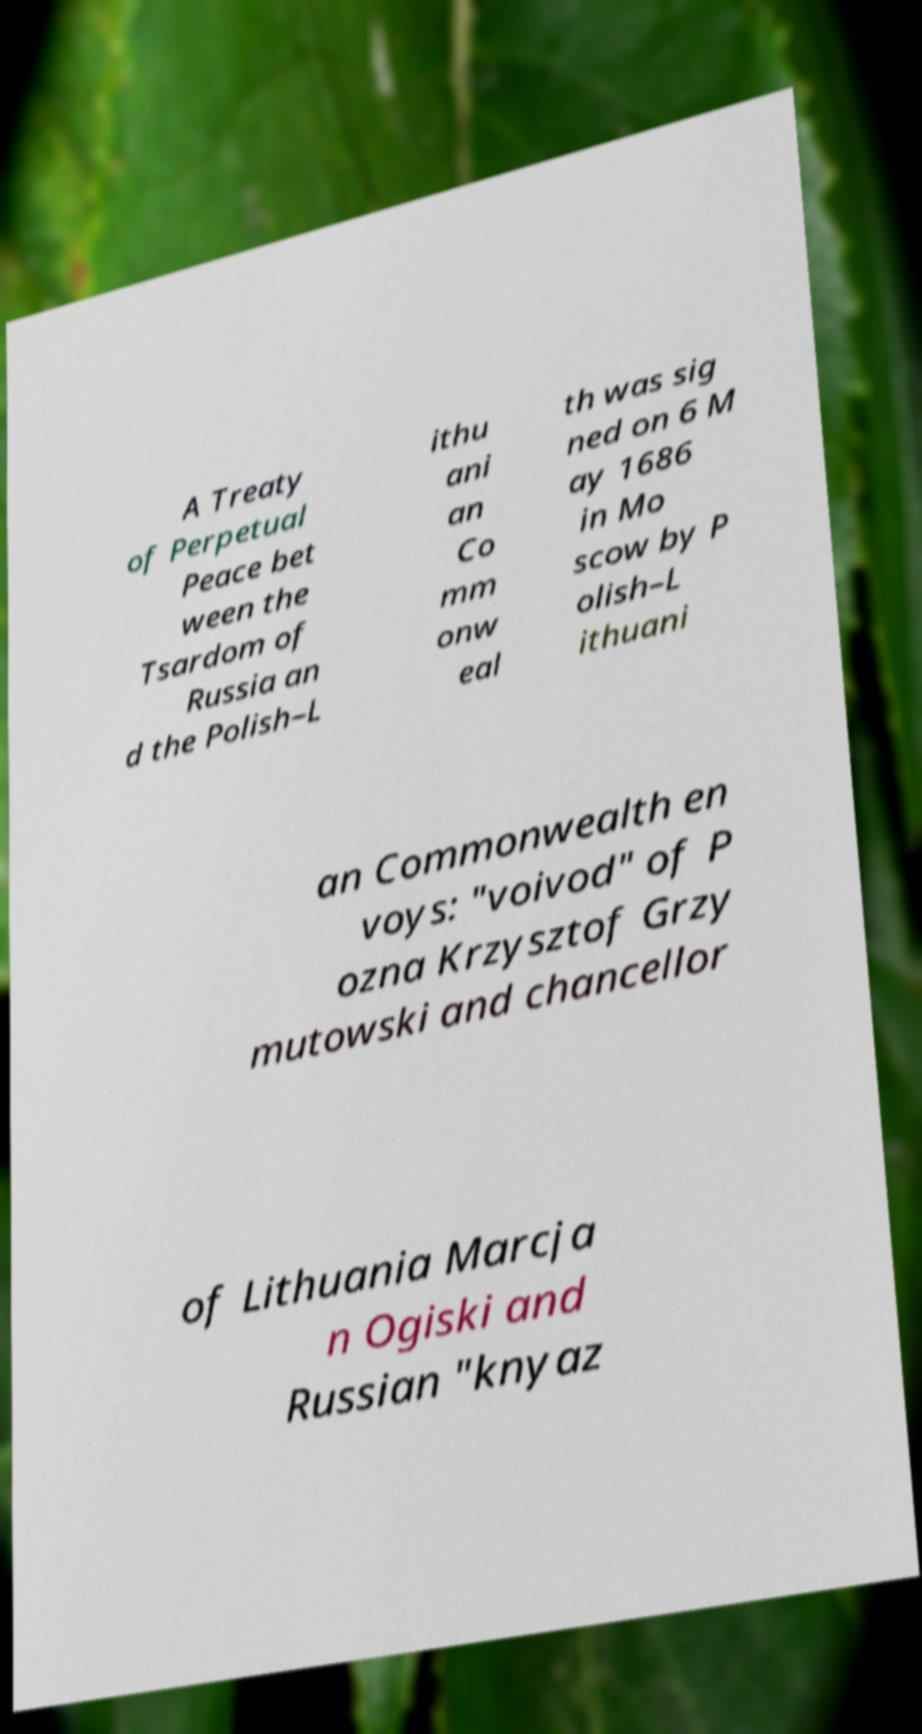Could you extract and type out the text from this image? A Treaty of Perpetual Peace bet ween the Tsardom of Russia an d the Polish–L ithu ani an Co mm onw eal th was sig ned on 6 M ay 1686 in Mo scow by P olish–L ithuani an Commonwealth en voys: "voivod" of P ozna Krzysztof Grzy mutowski and chancellor of Lithuania Marcja n Ogiski and Russian "knyaz 